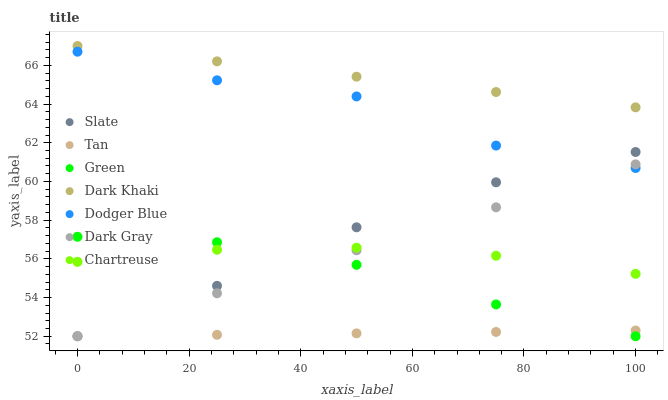Does Tan have the minimum area under the curve?
Answer yes or no. Yes. Does Dark Khaki have the maximum area under the curve?
Answer yes or no. Yes. Does Slate have the minimum area under the curve?
Answer yes or no. No. Does Slate have the maximum area under the curve?
Answer yes or no. No. Is Dark Khaki the smoothest?
Answer yes or no. Yes. Is Dodger Blue the roughest?
Answer yes or no. Yes. Is Slate the smoothest?
Answer yes or no. No. Is Slate the roughest?
Answer yes or no. No. Does Dark Gray have the lowest value?
Answer yes or no. Yes. Does Dark Khaki have the lowest value?
Answer yes or no. No. Does Dark Khaki have the highest value?
Answer yes or no. Yes. Does Slate have the highest value?
Answer yes or no. No. Is Tan less than Dark Khaki?
Answer yes or no. Yes. Is Dark Khaki greater than Tan?
Answer yes or no. Yes. Does Chartreuse intersect Green?
Answer yes or no. Yes. Is Chartreuse less than Green?
Answer yes or no. No. Is Chartreuse greater than Green?
Answer yes or no. No. Does Tan intersect Dark Khaki?
Answer yes or no. No. 